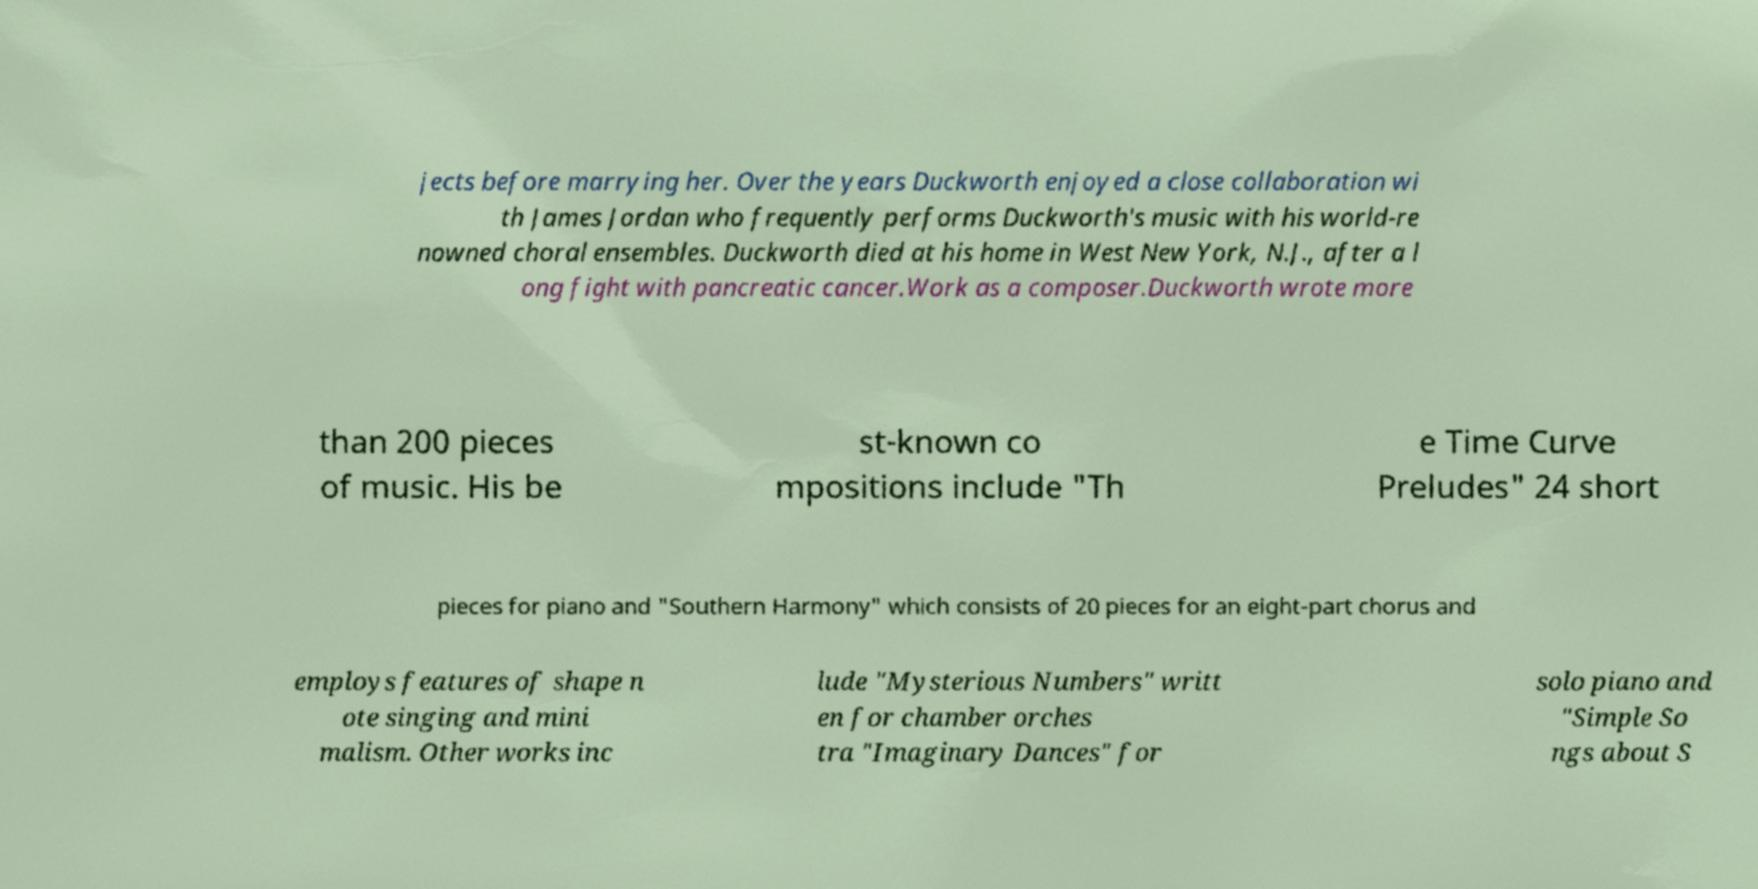Can you read and provide the text displayed in the image?This photo seems to have some interesting text. Can you extract and type it out for me? jects before marrying her. Over the years Duckworth enjoyed a close collaboration wi th James Jordan who frequently performs Duckworth's music with his world-re nowned choral ensembles. Duckworth died at his home in West New York, N.J., after a l ong fight with pancreatic cancer.Work as a composer.Duckworth wrote more than 200 pieces of music. His be st-known co mpositions include "Th e Time Curve Preludes" 24 short pieces for piano and "Southern Harmony" which consists of 20 pieces for an eight-part chorus and employs features of shape n ote singing and mini malism. Other works inc lude "Mysterious Numbers" writt en for chamber orches tra "Imaginary Dances" for solo piano and "Simple So ngs about S 